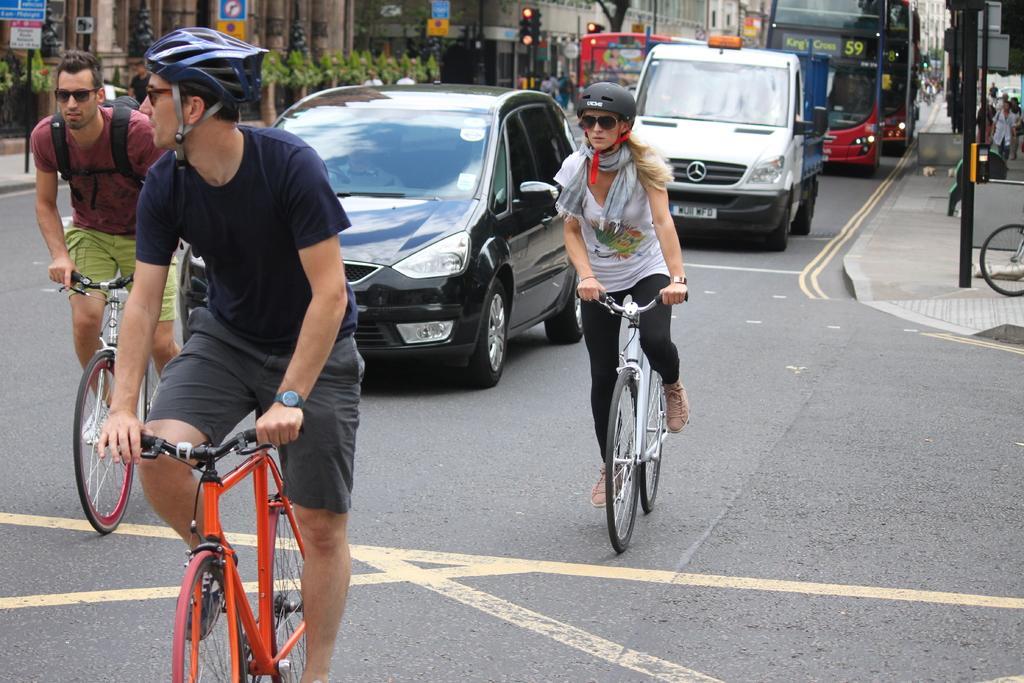Please provide a concise description of this image. in this image on the street there are many cars and there are many people are there and some of people they are riding the bicycle and both the persons are wearing the t-shirt and Bermuda and another girl she is wearing a t-shirt and pant... 